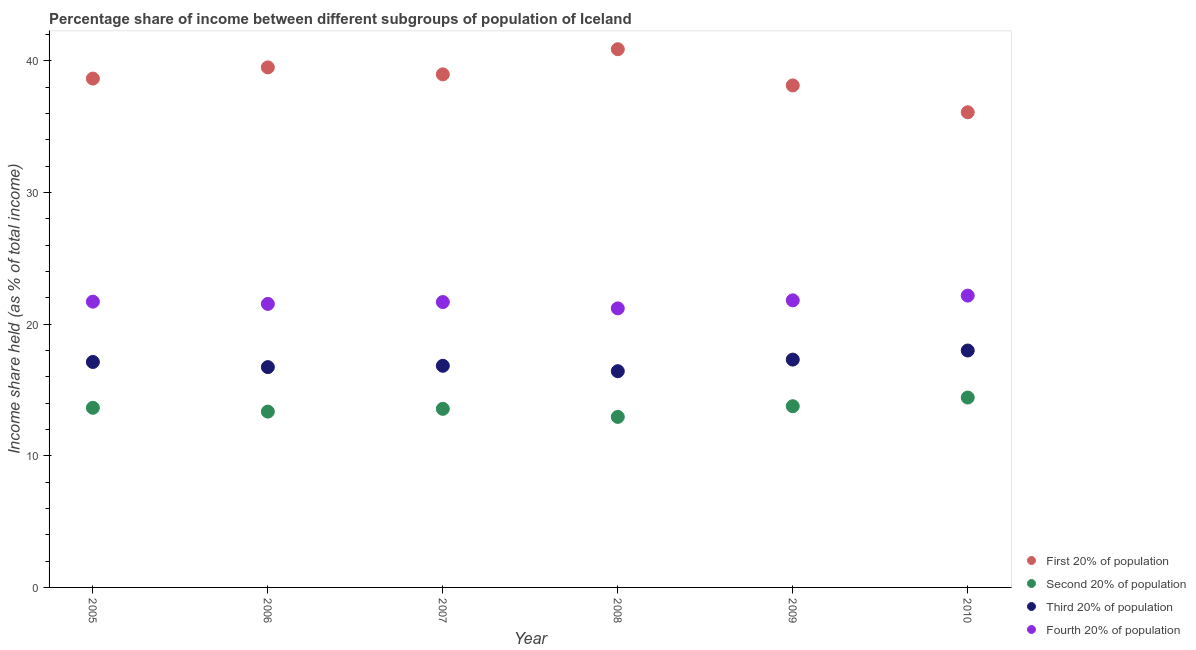How many different coloured dotlines are there?
Your response must be concise. 4. Is the number of dotlines equal to the number of legend labels?
Your answer should be very brief. Yes. What is the share of the income held by fourth 20% of the population in 2008?
Offer a terse response. 21.19. Across all years, what is the maximum share of the income held by fourth 20% of the population?
Offer a very short reply. 22.16. Across all years, what is the minimum share of the income held by first 20% of the population?
Ensure brevity in your answer.  36.08. What is the total share of the income held by fourth 20% of the population in the graph?
Your answer should be very brief. 130.05. What is the difference between the share of the income held by fourth 20% of the population in 2006 and that in 2008?
Your answer should be very brief. 0.34. What is the difference between the share of the income held by second 20% of the population in 2007 and the share of the income held by third 20% of the population in 2009?
Ensure brevity in your answer.  -3.74. What is the average share of the income held by second 20% of the population per year?
Ensure brevity in your answer.  13.61. In the year 2009, what is the difference between the share of the income held by second 20% of the population and share of the income held by third 20% of the population?
Your answer should be very brief. -3.54. What is the ratio of the share of the income held by fourth 20% of the population in 2005 to that in 2009?
Provide a short and direct response. 1. Is the share of the income held by second 20% of the population in 2005 less than that in 2006?
Your answer should be compact. No. What is the difference between the highest and the second highest share of the income held by fourth 20% of the population?
Your answer should be compact. 0.36. What is the difference between the highest and the lowest share of the income held by second 20% of the population?
Keep it short and to the point. 1.47. In how many years, is the share of the income held by second 20% of the population greater than the average share of the income held by second 20% of the population taken over all years?
Provide a succinct answer. 3. Is the sum of the share of the income held by third 20% of the population in 2007 and 2009 greater than the maximum share of the income held by second 20% of the population across all years?
Offer a very short reply. Yes. Is it the case that in every year, the sum of the share of the income held by first 20% of the population and share of the income held by fourth 20% of the population is greater than the sum of share of the income held by third 20% of the population and share of the income held by second 20% of the population?
Your answer should be compact. Yes. How many dotlines are there?
Provide a succinct answer. 4. What is the difference between two consecutive major ticks on the Y-axis?
Offer a terse response. 10. Does the graph contain grids?
Provide a succinct answer. No. How many legend labels are there?
Make the answer very short. 4. How are the legend labels stacked?
Make the answer very short. Vertical. What is the title of the graph?
Your answer should be compact. Percentage share of income between different subgroups of population of Iceland. What is the label or title of the X-axis?
Your response must be concise. Year. What is the label or title of the Y-axis?
Your answer should be compact. Income share held (as % of total income). What is the Income share held (as % of total income) of First 20% of population in 2005?
Give a very brief answer. 38.64. What is the Income share held (as % of total income) in Second 20% of population in 2005?
Make the answer very short. 13.64. What is the Income share held (as % of total income) in Third 20% of population in 2005?
Provide a succinct answer. 17.12. What is the Income share held (as % of total income) of Fourth 20% of population in 2005?
Give a very brief answer. 21.7. What is the Income share held (as % of total income) in First 20% of population in 2006?
Make the answer very short. 39.49. What is the Income share held (as % of total income) of Second 20% of population in 2006?
Ensure brevity in your answer.  13.35. What is the Income share held (as % of total income) in Third 20% of population in 2006?
Make the answer very short. 16.73. What is the Income share held (as % of total income) of Fourth 20% of population in 2006?
Make the answer very short. 21.53. What is the Income share held (as % of total income) in First 20% of population in 2007?
Make the answer very short. 38.96. What is the Income share held (as % of total income) of Second 20% of population in 2007?
Ensure brevity in your answer.  13.56. What is the Income share held (as % of total income) of Third 20% of population in 2007?
Keep it short and to the point. 16.83. What is the Income share held (as % of total income) in Fourth 20% of population in 2007?
Keep it short and to the point. 21.67. What is the Income share held (as % of total income) in First 20% of population in 2008?
Offer a very short reply. 40.87. What is the Income share held (as % of total income) in Second 20% of population in 2008?
Provide a succinct answer. 12.95. What is the Income share held (as % of total income) of Third 20% of population in 2008?
Offer a very short reply. 16.42. What is the Income share held (as % of total income) in Fourth 20% of population in 2008?
Make the answer very short. 21.19. What is the Income share held (as % of total income) of First 20% of population in 2009?
Make the answer very short. 38.12. What is the Income share held (as % of total income) of Second 20% of population in 2009?
Your answer should be compact. 13.76. What is the Income share held (as % of total income) of Third 20% of population in 2009?
Your answer should be very brief. 17.3. What is the Income share held (as % of total income) of Fourth 20% of population in 2009?
Provide a succinct answer. 21.8. What is the Income share held (as % of total income) in First 20% of population in 2010?
Provide a short and direct response. 36.08. What is the Income share held (as % of total income) of Second 20% of population in 2010?
Give a very brief answer. 14.42. What is the Income share held (as % of total income) in Third 20% of population in 2010?
Ensure brevity in your answer.  17.99. What is the Income share held (as % of total income) in Fourth 20% of population in 2010?
Give a very brief answer. 22.16. Across all years, what is the maximum Income share held (as % of total income) in First 20% of population?
Your answer should be very brief. 40.87. Across all years, what is the maximum Income share held (as % of total income) in Second 20% of population?
Your answer should be compact. 14.42. Across all years, what is the maximum Income share held (as % of total income) in Third 20% of population?
Ensure brevity in your answer.  17.99. Across all years, what is the maximum Income share held (as % of total income) in Fourth 20% of population?
Keep it short and to the point. 22.16. Across all years, what is the minimum Income share held (as % of total income) in First 20% of population?
Your answer should be compact. 36.08. Across all years, what is the minimum Income share held (as % of total income) in Second 20% of population?
Ensure brevity in your answer.  12.95. Across all years, what is the minimum Income share held (as % of total income) in Third 20% of population?
Make the answer very short. 16.42. Across all years, what is the minimum Income share held (as % of total income) in Fourth 20% of population?
Your answer should be very brief. 21.19. What is the total Income share held (as % of total income) in First 20% of population in the graph?
Provide a succinct answer. 232.16. What is the total Income share held (as % of total income) of Second 20% of population in the graph?
Keep it short and to the point. 81.68. What is the total Income share held (as % of total income) in Third 20% of population in the graph?
Offer a terse response. 102.39. What is the total Income share held (as % of total income) of Fourth 20% of population in the graph?
Offer a terse response. 130.05. What is the difference between the Income share held (as % of total income) in First 20% of population in 2005 and that in 2006?
Make the answer very short. -0.85. What is the difference between the Income share held (as % of total income) of Second 20% of population in 2005 and that in 2006?
Give a very brief answer. 0.29. What is the difference between the Income share held (as % of total income) in Third 20% of population in 2005 and that in 2006?
Keep it short and to the point. 0.39. What is the difference between the Income share held (as % of total income) of Fourth 20% of population in 2005 and that in 2006?
Provide a short and direct response. 0.17. What is the difference between the Income share held (as % of total income) of First 20% of population in 2005 and that in 2007?
Provide a short and direct response. -0.32. What is the difference between the Income share held (as % of total income) in Third 20% of population in 2005 and that in 2007?
Offer a terse response. 0.29. What is the difference between the Income share held (as % of total income) of Fourth 20% of population in 2005 and that in 2007?
Keep it short and to the point. 0.03. What is the difference between the Income share held (as % of total income) of First 20% of population in 2005 and that in 2008?
Make the answer very short. -2.23. What is the difference between the Income share held (as % of total income) in Second 20% of population in 2005 and that in 2008?
Keep it short and to the point. 0.69. What is the difference between the Income share held (as % of total income) of Fourth 20% of population in 2005 and that in 2008?
Offer a terse response. 0.51. What is the difference between the Income share held (as % of total income) of First 20% of population in 2005 and that in 2009?
Offer a very short reply. 0.52. What is the difference between the Income share held (as % of total income) in Second 20% of population in 2005 and that in 2009?
Your answer should be very brief. -0.12. What is the difference between the Income share held (as % of total income) in Third 20% of population in 2005 and that in 2009?
Ensure brevity in your answer.  -0.18. What is the difference between the Income share held (as % of total income) of Fourth 20% of population in 2005 and that in 2009?
Make the answer very short. -0.1. What is the difference between the Income share held (as % of total income) of First 20% of population in 2005 and that in 2010?
Provide a short and direct response. 2.56. What is the difference between the Income share held (as % of total income) of Second 20% of population in 2005 and that in 2010?
Offer a very short reply. -0.78. What is the difference between the Income share held (as % of total income) of Third 20% of population in 2005 and that in 2010?
Offer a very short reply. -0.87. What is the difference between the Income share held (as % of total income) in Fourth 20% of population in 2005 and that in 2010?
Provide a succinct answer. -0.46. What is the difference between the Income share held (as % of total income) in First 20% of population in 2006 and that in 2007?
Offer a very short reply. 0.53. What is the difference between the Income share held (as % of total income) of Second 20% of population in 2006 and that in 2007?
Offer a very short reply. -0.21. What is the difference between the Income share held (as % of total income) in Fourth 20% of population in 2006 and that in 2007?
Offer a very short reply. -0.14. What is the difference between the Income share held (as % of total income) of First 20% of population in 2006 and that in 2008?
Offer a terse response. -1.38. What is the difference between the Income share held (as % of total income) of Third 20% of population in 2006 and that in 2008?
Your response must be concise. 0.31. What is the difference between the Income share held (as % of total income) in Fourth 20% of population in 2006 and that in 2008?
Your response must be concise. 0.34. What is the difference between the Income share held (as % of total income) of First 20% of population in 2006 and that in 2009?
Your answer should be very brief. 1.37. What is the difference between the Income share held (as % of total income) of Second 20% of population in 2006 and that in 2009?
Your answer should be compact. -0.41. What is the difference between the Income share held (as % of total income) in Third 20% of population in 2006 and that in 2009?
Offer a very short reply. -0.57. What is the difference between the Income share held (as % of total income) of Fourth 20% of population in 2006 and that in 2009?
Your response must be concise. -0.27. What is the difference between the Income share held (as % of total income) of First 20% of population in 2006 and that in 2010?
Provide a succinct answer. 3.41. What is the difference between the Income share held (as % of total income) of Second 20% of population in 2006 and that in 2010?
Offer a very short reply. -1.07. What is the difference between the Income share held (as % of total income) of Third 20% of population in 2006 and that in 2010?
Ensure brevity in your answer.  -1.26. What is the difference between the Income share held (as % of total income) of Fourth 20% of population in 2006 and that in 2010?
Ensure brevity in your answer.  -0.63. What is the difference between the Income share held (as % of total income) of First 20% of population in 2007 and that in 2008?
Your answer should be very brief. -1.91. What is the difference between the Income share held (as % of total income) in Second 20% of population in 2007 and that in 2008?
Your response must be concise. 0.61. What is the difference between the Income share held (as % of total income) in Third 20% of population in 2007 and that in 2008?
Offer a terse response. 0.41. What is the difference between the Income share held (as % of total income) of Fourth 20% of population in 2007 and that in 2008?
Offer a terse response. 0.48. What is the difference between the Income share held (as % of total income) in First 20% of population in 2007 and that in 2009?
Your answer should be compact. 0.84. What is the difference between the Income share held (as % of total income) of Second 20% of population in 2007 and that in 2009?
Your response must be concise. -0.2. What is the difference between the Income share held (as % of total income) in Third 20% of population in 2007 and that in 2009?
Your answer should be very brief. -0.47. What is the difference between the Income share held (as % of total income) of Fourth 20% of population in 2007 and that in 2009?
Offer a terse response. -0.13. What is the difference between the Income share held (as % of total income) of First 20% of population in 2007 and that in 2010?
Provide a succinct answer. 2.88. What is the difference between the Income share held (as % of total income) in Second 20% of population in 2007 and that in 2010?
Offer a very short reply. -0.86. What is the difference between the Income share held (as % of total income) in Third 20% of population in 2007 and that in 2010?
Your response must be concise. -1.16. What is the difference between the Income share held (as % of total income) in Fourth 20% of population in 2007 and that in 2010?
Your response must be concise. -0.49. What is the difference between the Income share held (as % of total income) in First 20% of population in 2008 and that in 2009?
Your answer should be compact. 2.75. What is the difference between the Income share held (as % of total income) of Second 20% of population in 2008 and that in 2009?
Keep it short and to the point. -0.81. What is the difference between the Income share held (as % of total income) of Third 20% of population in 2008 and that in 2009?
Ensure brevity in your answer.  -0.88. What is the difference between the Income share held (as % of total income) of Fourth 20% of population in 2008 and that in 2009?
Give a very brief answer. -0.61. What is the difference between the Income share held (as % of total income) in First 20% of population in 2008 and that in 2010?
Your answer should be very brief. 4.79. What is the difference between the Income share held (as % of total income) of Second 20% of population in 2008 and that in 2010?
Your answer should be very brief. -1.47. What is the difference between the Income share held (as % of total income) of Third 20% of population in 2008 and that in 2010?
Ensure brevity in your answer.  -1.57. What is the difference between the Income share held (as % of total income) of Fourth 20% of population in 2008 and that in 2010?
Make the answer very short. -0.97. What is the difference between the Income share held (as % of total income) of First 20% of population in 2009 and that in 2010?
Give a very brief answer. 2.04. What is the difference between the Income share held (as % of total income) in Second 20% of population in 2009 and that in 2010?
Offer a very short reply. -0.66. What is the difference between the Income share held (as % of total income) of Third 20% of population in 2009 and that in 2010?
Give a very brief answer. -0.69. What is the difference between the Income share held (as % of total income) in Fourth 20% of population in 2009 and that in 2010?
Offer a terse response. -0.36. What is the difference between the Income share held (as % of total income) in First 20% of population in 2005 and the Income share held (as % of total income) in Second 20% of population in 2006?
Provide a short and direct response. 25.29. What is the difference between the Income share held (as % of total income) in First 20% of population in 2005 and the Income share held (as % of total income) in Third 20% of population in 2006?
Offer a very short reply. 21.91. What is the difference between the Income share held (as % of total income) in First 20% of population in 2005 and the Income share held (as % of total income) in Fourth 20% of population in 2006?
Your response must be concise. 17.11. What is the difference between the Income share held (as % of total income) of Second 20% of population in 2005 and the Income share held (as % of total income) of Third 20% of population in 2006?
Your response must be concise. -3.09. What is the difference between the Income share held (as % of total income) of Second 20% of population in 2005 and the Income share held (as % of total income) of Fourth 20% of population in 2006?
Offer a very short reply. -7.89. What is the difference between the Income share held (as % of total income) in Third 20% of population in 2005 and the Income share held (as % of total income) in Fourth 20% of population in 2006?
Your answer should be very brief. -4.41. What is the difference between the Income share held (as % of total income) in First 20% of population in 2005 and the Income share held (as % of total income) in Second 20% of population in 2007?
Give a very brief answer. 25.08. What is the difference between the Income share held (as % of total income) in First 20% of population in 2005 and the Income share held (as % of total income) in Third 20% of population in 2007?
Your response must be concise. 21.81. What is the difference between the Income share held (as % of total income) in First 20% of population in 2005 and the Income share held (as % of total income) in Fourth 20% of population in 2007?
Ensure brevity in your answer.  16.97. What is the difference between the Income share held (as % of total income) in Second 20% of population in 2005 and the Income share held (as % of total income) in Third 20% of population in 2007?
Provide a short and direct response. -3.19. What is the difference between the Income share held (as % of total income) of Second 20% of population in 2005 and the Income share held (as % of total income) of Fourth 20% of population in 2007?
Your answer should be very brief. -8.03. What is the difference between the Income share held (as % of total income) in Third 20% of population in 2005 and the Income share held (as % of total income) in Fourth 20% of population in 2007?
Give a very brief answer. -4.55. What is the difference between the Income share held (as % of total income) of First 20% of population in 2005 and the Income share held (as % of total income) of Second 20% of population in 2008?
Your answer should be compact. 25.69. What is the difference between the Income share held (as % of total income) in First 20% of population in 2005 and the Income share held (as % of total income) in Third 20% of population in 2008?
Make the answer very short. 22.22. What is the difference between the Income share held (as % of total income) of First 20% of population in 2005 and the Income share held (as % of total income) of Fourth 20% of population in 2008?
Keep it short and to the point. 17.45. What is the difference between the Income share held (as % of total income) of Second 20% of population in 2005 and the Income share held (as % of total income) of Third 20% of population in 2008?
Offer a very short reply. -2.78. What is the difference between the Income share held (as % of total income) in Second 20% of population in 2005 and the Income share held (as % of total income) in Fourth 20% of population in 2008?
Your response must be concise. -7.55. What is the difference between the Income share held (as % of total income) in Third 20% of population in 2005 and the Income share held (as % of total income) in Fourth 20% of population in 2008?
Give a very brief answer. -4.07. What is the difference between the Income share held (as % of total income) in First 20% of population in 2005 and the Income share held (as % of total income) in Second 20% of population in 2009?
Your answer should be very brief. 24.88. What is the difference between the Income share held (as % of total income) in First 20% of population in 2005 and the Income share held (as % of total income) in Third 20% of population in 2009?
Offer a terse response. 21.34. What is the difference between the Income share held (as % of total income) of First 20% of population in 2005 and the Income share held (as % of total income) of Fourth 20% of population in 2009?
Provide a succinct answer. 16.84. What is the difference between the Income share held (as % of total income) in Second 20% of population in 2005 and the Income share held (as % of total income) in Third 20% of population in 2009?
Provide a short and direct response. -3.66. What is the difference between the Income share held (as % of total income) in Second 20% of population in 2005 and the Income share held (as % of total income) in Fourth 20% of population in 2009?
Give a very brief answer. -8.16. What is the difference between the Income share held (as % of total income) in Third 20% of population in 2005 and the Income share held (as % of total income) in Fourth 20% of population in 2009?
Ensure brevity in your answer.  -4.68. What is the difference between the Income share held (as % of total income) in First 20% of population in 2005 and the Income share held (as % of total income) in Second 20% of population in 2010?
Your answer should be very brief. 24.22. What is the difference between the Income share held (as % of total income) of First 20% of population in 2005 and the Income share held (as % of total income) of Third 20% of population in 2010?
Give a very brief answer. 20.65. What is the difference between the Income share held (as % of total income) in First 20% of population in 2005 and the Income share held (as % of total income) in Fourth 20% of population in 2010?
Keep it short and to the point. 16.48. What is the difference between the Income share held (as % of total income) in Second 20% of population in 2005 and the Income share held (as % of total income) in Third 20% of population in 2010?
Provide a short and direct response. -4.35. What is the difference between the Income share held (as % of total income) in Second 20% of population in 2005 and the Income share held (as % of total income) in Fourth 20% of population in 2010?
Your response must be concise. -8.52. What is the difference between the Income share held (as % of total income) in Third 20% of population in 2005 and the Income share held (as % of total income) in Fourth 20% of population in 2010?
Your answer should be compact. -5.04. What is the difference between the Income share held (as % of total income) in First 20% of population in 2006 and the Income share held (as % of total income) in Second 20% of population in 2007?
Provide a succinct answer. 25.93. What is the difference between the Income share held (as % of total income) of First 20% of population in 2006 and the Income share held (as % of total income) of Third 20% of population in 2007?
Keep it short and to the point. 22.66. What is the difference between the Income share held (as % of total income) in First 20% of population in 2006 and the Income share held (as % of total income) in Fourth 20% of population in 2007?
Make the answer very short. 17.82. What is the difference between the Income share held (as % of total income) in Second 20% of population in 2006 and the Income share held (as % of total income) in Third 20% of population in 2007?
Your answer should be compact. -3.48. What is the difference between the Income share held (as % of total income) in Second 20% of population in 2006 and the Income share held (as % of total income) in Fourth 20% of population in 2007?
Offer a terse response. -8.32. What is the difference between the Income share held (as % of total income) of Third 20% of population in 2006 and the Income share held (as % of total income) of Fourth 20% of population in 2007?
Offer a very short reply. -4.94. What is the difference between the Income share held (as % of total income) of First 20% of population in 2006 and the Income share held (as % of total income) of Second 20% of population in 2008?
Ensure brevity in your answer.  26.54. What is the difference between the Income share held (as % of total income) in First 20% of population in 2006 and the Income share held (as % of total income) in Third 20% of population in 2008?
Your answer should be compact. 23.07. What is the difference between the Income share held (as % of total income) in Second 20% of population in 2006 and the Income share held (as % of total income) in Third 20% of population in 2008?
Ensure brevity in your answer.  -3.07. What is the difference between the Income share held (as % of total income) in Second 20% of population in 2006 and the Income share held (as % of total income) in Fourth 20% of population in 2008?
Give a very brief answer. -7.84. What is the difference between the Income share held (as % of total income) of Third 20% of population in 2006 and the Income share held (as % of total income) of Fourth 20% of population in 2008?
Ensure brevity in your answer.  -4.46. What is the difference between the Income share held (as % of total income) in First 20% of population in 2006 and the Income share held (as % of total income) in Second 20% of population in 2009?
Offer a terse response. 25.73. What is the difference between the Income share held (as % of total income) of First 20% of population in 2006 and the Income share held (as % of total income) of Third 20% of population in 2009?
Provide a short and direct response. 22.19. What is the difference between the Income share held (as % of total income) in First 20% of population in 2006 and the Income share held (as % of total income) in Fourth 20% of population in 2009?
Your response must be concise. 17.69. What is the difference between the Income share held (as % of total income) of Second 20% of population in 2006 and the Income share held (as % of total income) of Third 20% of population in 2009?
Keep it short and to the point. -3.95. What is the difference between the Income share held (as % of total income) of Second 20% of population in 2006 and the Income share held (as % of total income) of Fourth 20% of population in 2009?
Keep it short and to the point. -8.45. What is the difference between the Income share held (as % of total income) in Third 20% of population in 2006 and the Income share held (as % of total income) in Fourth 20% of population in 2009?
Provide a short and direct response. -5.07. What is the difference between the Income share held (as % of total income) of First 20% of population in 2006 and the Income share held (as % of total income) of Second 20% of population in 2010?
Your answer should be compact. 25.07. What is the difference between the Income share held (as % of total income) in First 20% of population in 2006 and the Income share held (as % of total income) in Fourth 20% of population in 2010?
Give a very brief answer. 17.33. What is the difference between the Income share held (as % of total income) in Second 20% of population in 2006 and the Income share held (as % of total income) in Third 20% of population in 2010?
Your response must be concise. -4.64. What is the difference between the Income share held (as % of total income) of Second 20% of population in 2006 and the Income share held (as % of total income) of Fourth 20% of population in 2010?
Your response must be concise. -8.81. What is the difference between the Income share held (as % of total income) in Third 20% of population in 2006 and the Income share held (as % of total income) in Fourth 20% of population in 2010?
Make the answer very short. -5.43. What is the difference between the Income share held (as % of total income) in First 20% of population in 2007 and the Income share held (as % of total income) in Second 20% of population in 2008?
Offer a very short reply. 26.01. What is the difference between the Income share held (as % of total income) in First 20% of population in 2007 and the Income share held (as % of total income) in Third 20% of population in 2008?
Ensure brevity in your answer.  22.54. What is the difference between the Income share held (as % of total income) of First 20% of population in 2007 and the Income share held (as % of total income) of Fourth 20% of population in 2008?
Provide a short and direct response. 17.77. What is the difference between the Income share held (as % of total income) in Second 20% of population in 2007 and the Income share held (as % of total income) in Third 20% of population in 2008?
Your answer should be compact. -2.86. What is the difference between the Income share held (as % of total income) of Second 20% of population in 2007 and the Income share held (as % of total income) of Fourth 20% of population in 2008?
Offer a terse response. -7.63. What is the difference between the Income share held (as % of total income) in Third 20% of population in 2007 and the Income share held (as % of total income) in Fourth 20% of population in 2008?
Your answer should be very brief. -4.36. What is the difference between the Income share held (as % of total income) of First 20% of population in 2007 and the Income share held (as % of total income) of Second 20% of population in 2009?
Your answer should be compact. 25.2. What is the difference between the Income share held (as % of total income) of First 20% of population in 2007 and the Income share held (as % of total income) of Third 20% of population in 2009?
Provide a succinct answer. 21.66. What is the difference between the Income share held (as % of total income) in First 20% of population in 2007 and the Income share held (as % of total income) in Fourth 20% of population in 2009?
Your response must be concise. 17.16. What is the difference between the Income share held (as % of total income) of Second 20% of population in 2007 and the Income share held (as % of total income) of Third 20% of population in 2009?
Ensure brevity in your answer.  -3.74. What is the difference between the Income share held (as % of total income) of Second 20% of population in 2007 and the Income share held (as % of total income) of Fourth 20% of population in 2009?
Offer a very short reply. -8.24. What is the difference between the Income share held (as % of total income) of Third 20% of population in 2007 and the Income share held (as % of total income) of Fourth 20% of population in 2009?
Offer a very short reply. -4.97. What is the difference between the Income share held (as % of total income) of First 20% of population in 2007 and the Income share held (as % of total income) of Second 20% of population in 2010?
Make the answer very short. 24.54. What is the difference between the Income share held (as % of total income) of First 20% of population in 2007 and the Income share held (as % of total income) of Third 20% of population in 2010?
Provide a succinct answer. 20.97. What is the difference between the Income share held (as % of total income) in Second 20% of population in 2007 and the Income share held (as % of total income) in Third 20% of population in 2010?
Provide a succinct answer. -4.43. What is the difference between the Income share held (as % of total income) of Second 20% of population in 2007 and the Income share held (as % of total income) of Fourth 20% of population in 2010?
Keep it short and to the point. -8.6. What is the difference between the Income share held (as % of total income) of Third 20% of population in 2007 and the Income share held (as % of total income) of Fourth 20% of population in 2010?
Your response must be concise. -5.33. What is the difference between the Income share held (as % of total income) in First 20% of population in 2008 and the Income share held (as % of total income) in Second 20% of population in 2009?
Your answer should be very brief. 27.11. What is the difference between the Income share held (as % of total income) of First 20% of population in 2008 and the Income share held (as % of total income) of Third 20% of population in 2009?
Keep it short and to the point. 23.57. What is the difference between the Income share held (as % of total income) in First 20% of population in 2008 and the Income share held (as % of total income) in Fourth 20% of population in 2009?
Ensure brevity in your answer.  19.07. What is the difference between the Income share held (as % of total income) in Second 20% of population in 2008 and the Income share held (as % of total income) in Third 20% of population in 2009?
Provide a succinct answer. -4.35. What is the difference between the Income share held (as % of total income) in Second 20% of population in 2008 and the Income share held (as % of total income) in Fourth 20% of population in 2009?
Your answer should be compact. -8.85. What is the difference between the Income share held (as % of total income) in Third 20% of population in 2008 and the Income share held (as % of total income) in Fourth 20% of population in 2009?
Offer a very short reply. -5.38. What is the difference between the Income share held (as % of total income) in First 20% of population in 2008 and the Income share held (as % of total income) in Second 20% of population in 2010?
Your response must be concise. 26.45. What is the difference between the Income share held (as % of total income) of First 20% of population in 2008 and the Income share held (as % of total income) of Third 20% of population in 2010?
Your response must be concise. 22.88. What is the difference between the Income share held (as % of total income) of First 20% of population in 2008 and the Income share held (as % of total income) of Fourth 20% of population in 2010?
Your response must be concise. 18.71. What is the difference between the Income share held (as % of total income) in Second 20% of population in 2008 and the Income share held (as % of total income) in Third 20% of population in 2010?
Offer a very short reply. -5.04. What is the difference between the Income share held (as % of total income) in Second 20% of population in 2008 and the Income share held (as % of total income) in Fourth 20% of population in 2010?
Ensure brevity in your answer.  -9.21. What is the difference between the Income share held (as % of total income) of Third 20% of population in 2008 and the Income share held (as % of total income) of Fourth 20% of population in 2010?
Your answer should be compact. -5.74. What is the difference between the Income share held (as % of total income) in First 20% of population in 2009 and the Income share held (as % of total income) in Second 20% of population in 2010?
Offer a very short reply. 23.7. What is the difference between the Income share held (as % of total income) of First 20% of population in 2009 and the Income share held (as % of total income) of Third 20% of population in 2010?
Provide a short and direct response. 20.13. What is the difference between the Income share held (as % of total income) of First 20% of population in 2009 and the Income share held (as % of total income) of Fourth 20% of population in 2010?
Your answer should be very brief. 15.96. What is the difference between the Income share held (as % of total income) in Second 20% of population in 2009 and the Income share held (as % of total income) in Third 20% of population in 2010?
Offer a terse response. -4.23. What is the difference between the Income share held (as % of total income) of Second 20% of population in 2009 and the Income share held (as % of total income) of Fourth 20% of population in 2010?
Give a very brief answer. -8.4. What is the difference between the Income share held (as % of total income) of Third 20% of population in 2009 and the Income share held (as % of total income) of Fourth 20% of population in 2010?
Your answer should be very brief. -4.86. What is the average Income share held (as % of total income) in First 20% of population per year?
Ensure brevity in your answer.  38.69. What is the average Income share held (as % of total income) in Second 20% of population per year?
Ensure brevity in your answer.  13.61. What is the average Income share held (as % of total income) in Third 20% of population per year?
Make the answer very short. 17.07. What is the average Income share held (as % of total income) of Fourth 20% of population per year?
Make the answer very short. 21.68. In the year 2005, what is the difference between the Income share held (as % of total income) in First 20% of population and Income share held (as % of total income) in Second 20% of population?
Ensure brevity in your answer.  25. In the year 2005, what is the difference between the Income share held (as % of total income) of First 20% of population and Income share held (as % of total income) of Third 20% of population?
Your response must be concise. 21.52. In the year 2005, what is the difference between the Income share held (as % of total income) in First 20% of population and Income share held (as % of total income) in Fourth 20% of population?
Offer a terse response. 16.94. In the year 2005, what is the difference between the Income share held (as % of total income) of Second 20% of population and Income share held (as % of total income) of Third 20% of population?
Your response must be concise. -3.48. In the year 2005, what is the difference between the Income share held (as % of total income) of Second 20% of population and Income share held (as % of total income) of Fourth 20% of population?
Provide a succinct answer. -8.06. In the year 2005, what is the difference between the Income share held (as % of total income) of Third 20% of population and Income share held (as % of total income) of Fourth 20% of population?
Keep it short and to the point. -4.58. In the year 2006, what is the difference between the Income share held (as % of total income) in First 20% of population and Income share held (as % of total income) in Second 20% of population?
Your answer should be compact. 26.14. In the year 2006, what is the difference between the Income share held (as % of total income) in First 20% of population and Income share held (as % of total income) in Third 20% of population?
Ensure brevity in your answer.  22.76. In the year 2006, what is the difference between the Income share held (as % of total income) of First 20% of population and Income share held (as % of total income) of Fourth 20% of population?
Your answer should be compact. 17.96. In the year 2006, what is the difference between the Income share held (as % of total income) in Second 20% of population and Income share held (as % of total income) in Third 20% of population?
Offer a terse response. -3.38. In the year 2006, what is the difference between the Income share held (as % of total income) in Second 20% of population and Income share held (as % of total income) in Fourth 20% of population?
Give a very brief answer. -8.18. In the year 2007, what is the difference between the Income share held (as % of total income) in First 20% of population and Income share held (as % of total income) in Second 20% of population?
Provide a short and direct response. 25.4. In the year 2007, what is the difference between the Income share held (as % of total income) of First 20% of population and Income share held (as % of total income) of Third 20% of population?
Make the answer very short. 22.13. In the year 2007, what is the difference between the Income share held (as % of total income) of First 20% of population and Income share held (as % of total income) of Fourth 20% of population?
Keep it short and to the point. 17.29. In the year 2007, what is the difference between the Income share held (as % of total income) of Second 20% of population and Income share held (as % of total income) of Third 20% of population?
Provide a short and direct response. -3.27. In the year 2007, what is the difference between the Income share held (as % of total income) in Second 20% of population and Income share held (as % of total income) in Fourth 20% of population?
Provide a short and direct response. -8.11. In the year 2007, what is the difference between the Income share held (as % of total income) of Third 20% of population and Income share held (as % of total income) of Fourth 20% of population?
Make the answer very short. -4.84. In the year 2008, what is the difference between the Income share held (as % of total income) in First 20% of population and Income share held (as % of total income) in Second 20% of population?
Ensure brevity in your answer.  27.92. In the year 2008, what is the difference between the Income share held (as % of total income) of First 20% of population and Income share held (as % of total income) of Third 20% of population?
Provide a succinct answer. 24.45. In the year 2008, what is the difference between the Income share held (as % of total income) in First 20% of population and Income share held (as % of total income) in Fourth 20% of population?
Give a very brief answer. 19.68. In the year 2008, what is the difference between the Income share held (as % of total income) of Second 20% of population and Income share held (as % of total income) of Third 20% of population?
Keep it short and to the point. -3.47. In the year 2008, what is the difference between the Income share held (as % of total income) in Second 20% of population and Income share held (as % of total income) in Fourth 20% of population?
Offer a very short reply. -8.24. In the year 2008, what is the difference between the Income share held (as % of total income) in Third 20% of population and Income share held (as % of total income) in Fourth 20% of population?
Give a very brief answer. -4.77. In the year 2009, what is the difference between the Income share held (as % of total income) in First 20% of population and Income share held (as % of total income) in Second 20% of population?
Offer a terse response. 24.36. In the year 2009, what is the difference between the Income share held (as % of total income) in First 20% of population and Income share held (as % of total income) in Third 20% of population?
Your answer should be compact. 20.82. In the year 2009, what is the difference between the Income share held (as % of total income) of First 20% of population and Income share held (as % of total income) of Fourth 20% of population?
Your answer should be compact. 16.32. In the year 2009, what is the difference between the Income share held (as % of total income) of Second 20% of population and Income share held (as % of total income) of Third 20% of population?
Your answer should be compact. -3.54. In the year 2009, what is the difference between the Income share held (as % of total income) of Second 20% of population and Income share held (as % of total income) of Fourth 20% of population?
Offer a very short reply. -8.04. In the year 2009, what is the difference between the Income share held (as % of total income) of Third 20% of population and Income share held (as % of total income) of Fourth 20% of population?
Your answer should be compact. -4.5. In the year 2010, what is the difference between the Income share held (as % of total income) in First 20% of population and Income share held (as % of total income) in Second 20% of population?
Provide a succinct answer. 21.66. In the year 2010, what is the difference between the Income share held (as % of total income) in First 20% of population and Income share held (as % of total income) in Third 20% of population?
Provide a succinct answer. 18.09. In the year 2010, what is the difference between the Income share held (as % of total income) of First 20% of population and Income share held (as % of total income) of Fourth 20% of population?
Ensure brevity in your answer.  13.92. In the year 2010, what is the difference between the Income share held (as % of total income) of Second 20% of population and Income share held (as % of total income) of Third 20% of population?
Your answer should be very brief. -3.57. In the year 2010, what is the difference between the Income share held (as % of total income) in Second 20% of population and Income share held (as % of total income) in Fourth 20% of population?
Ensure brevity in your answer.  -7.74. In the year 2010, what is the difference between the Income share held (as % of total income) of Third 20% of population and Income share held (as % of total income) of Fourth 20% of population?
Give a very brief answer. -4.17. What is the ratio of the Income share held (as % of total income) of First 20% of population in 2005 to that in 2006?
Your answer should be very brief. 0.98. What is the ratio of the Income share held (as % of total income) in Second 20% of population in 2005 to that in 2006?
Your answer should be compact. 1.02. What is the ratio of the Income share held (as % of total income) in Third 20% of population in 2005 to that in 2006?
Offer a terse response. 1.02. What is the ratio of the Income share held (as % of total income) of Fourth 20% of population in 2005 to that in 2006?
Give a very brief answer. 1.01. What is the ratio of the Income share held (as % of total income) of Second 20% of population in 2005 to that in 2007?
Your answer should be compact. 1.01. What is the ratio of the Income share held (as % of total income) in Third 20% of population in 2005 to that in 2007?
Offer a very short reply. 1.02. What is the ratio of the Income share held (as % of total income) in First 20% of population in 2005 to that in 2008?
Give a very brief answer. 0.95. What is the ratio of the Income share held (as % of total income) of Second 20% of population in 2005 to that in 2008?
Provide a succinct answer. 1.05. What is the ratio of the Income share held (as % of total income) of Third 20% of population in 2005 to that in 2008?
Keep it short and to the point. 1.04. What is the ratio of the Income share held (as % of total income) of Fourth 20% of population in 2005 to that in 2008?
Provide a succinct answer. 1.02. What is the ratio of the Income share held (as % of total income) in First 20% of population in 2005 to that in 2009?
Provide a short and direct response. 1.01. What is the ratio of the Income share held (as % of total income) in First 20% of population in 2005 to that in 2010?
Provide a short and direct response. 1.07. What is the ratio of the Income share held (as % of total income) in Second 20% of population in 2005 to that in 2010?
Offer a very short reply. 0.95. What is the ratio of the Income share held (as % of total income) of Third 20% of population in 2005 to that in 2010?
Offer a very short reply. 0.95. What is the ratio of the Income share held (as % of total income) in Fourth 20% of population in 2005 to that in 2010?
Your response must be concise. 0.98. What is the ratio of the Income share held (as % of total income) in First 20% of population in 2006 to that in 2007?
Keep it short and to the point. 1.01. What is the ratio of the Income share held (as % of total income) in Second 20% of population in 2006 to that in 2007?
Your response must be concise. 0.98. What is the ratio of the Income share held (as % of total income) of First 20% of population in 2006 to that in 2008?
Ensure brevity in your answer.  0.97. What is the ratio of the Income share held (as % of total income) of Second 20% of population in 2006 to that in 2008?
Ensure brevity in your answer.  1.03. What is the ratio of the Income share held (as % of total income) of Third 20% of population in 2006 to that in 2008?
Offer a terse response. 1.02. What is the ratio of the Income share held (as % of total income) of First 20% of population in 2006 to that in 2009?
Make the answer very short. 1.04. What is the ratio of the Income share held (as % of total income) of Second 20% of population in 2006 to that in 2009?
Ensure brevity in your answer.  0.97. What is the ratio of the Income share held (as % of total income) of Third 20% of population in 2006 to that in 2009?
Your answer should be compact. 0.97. What is the ratio of the Income share held (as % of total income) of Fourth 20% of population in 2006 to that in 2009?
Offer a very short reply. 0.99. What is the ratio of the Income share held (as % of total income) in First 20% of population in 2006 to that in 2010?
Offer a very short reply. 1.09. What is the ratio of the Income share held (as % of total income) of Second 20% of population in 2006 to that in 2010?
Your answer should be compact. 0.93. What is the ratio of the Income share held (as % of total income) in Third 20% of population in 2006 to that in 2010?
Provide a succinct answer. 0.93. What is the ratio of the Income share held (as % of total income) of Fourth 20% of population in 2006 to that in 2010?
Keep it short and to the point. 0.97. What is the ratio of the Income share held (as % of total income) in First 20% of population in 2007 to that in 2008?
Provide a succinct answer. 0.95. What is the ratio of the Income share held (as % of total income) of Second 20% of population in 2007 to that in 2008?
Ensure brevity in your answer.  1.05. What is the ratio of the Income share held (as % of total income) in Fourth 20% of population in 2007 to that in 2008?
Your answer should be compact. 1.02. What is the ratio of the Income share held (as % of total income) of First 20% of population in 2007 to that in 2009?
Your answer should be very brief. 1.02. What is the ratio of the Income share held (as % of total income) of Second 20% of population in 2007 to that in 2009?
Your answer should be compact. 0.99. What is the ratio of the Income share held (as % of total income) of Third 20% of population in 2007 to that in 2009?
Make the answer very short. 0.97. What is the ratio of the Income share held (as % of total income) of First 20% of population in 2007 to that in 2010?
Your answer should be very brief. 1.08. What is the ratio of the Income share held (as % of total income) of Second 20% of population in 2007 to that in 2010?
Your answer should be compact. 0.94. What is the ratio of the Income share held (as % of total income) of Third 20% of population in 2007 to that in 2010?
Provide a short and direct response. 0.94. What is the ratio of the Income share held (as % of total income) in Fourth 20% of population in 2007 to that in 2010?
Offer a very short reply. 0.98. What is the ratio of the Income share held (as % of total income) of First 20% of population in 2008 to that in 2009?
Provide a succinct answer. 1.07. What is the ratio of the Income share held (as % of total income) of Second 20% of population in 2008 to that in 2009?
Make the answer very short. 0.94. What is the ratio of the Income share held (as % of total income) in Third 20% of population in 2008 to that in 2009?
Keep it short and to the point. 0.95. What is the ratio of the Income share held (as % of total income) of Fourth 20% of population in 2008 to that in 2009?
Offer a terse response. 0.97. What is the ratio of the Income share held (as % of total income) in First 20% of population in 2008 to that in 2010?
Your answer should be compact. 1.13. What is the ratio of the Income share held (as % of total income) in Second 20% of population in 2008 to that in 2010?
Keep it short and to the point. 0.9. What is the ratio of the Income share held (as % of total income) of Third 20% of population in 2008 to that in 2010?
Your answer should be very brief. 0.91. What is the ratio of the Income share held (as % of total income) in Fourth 20% of population in 2008 to that in 2010?
Offer a very short reply. 0.96. What is the ratio of the Income share held (as % of total income) in First 20% of population in 2009 to that in 2010?
Provide a short and direct response. 1.06. What is the ratio of the Income share held (as % of total income) in Second 20% of population in 2009 to that in 2010?
Your answer should be very brief. 0.95. What is the ratio of the Income share held (as % of total income) in Third 20% of population in 2009 to that in 2010?
Offer a very short reply. 0.96. What is the ratio of the Income share held (as % of total income) in Fourth 20% of population in 2009 to that in 2010?
Give a very brief answer. 0.98. What is the difference between the highest and the second highest Income share held (as % of total income) in First 20% of population?
Your response must be concise. 1.38. What is the difference between the highest and the second highest Income share held (as % of total income) of Second 20% of population?
Offer a very short reply. 0.66. What is the difference between the highest and the second highest Income share held (as % of total income) in Third 20% of population?
Give a very brief answer. 0.69. What is the difference between the highest and the second highest Income share held (as % of total income) in Fourth 20% of population?
Keep it short and to the point. 0.36. What is the difference between the highest and the lowest Income share held (as % of total income) in First 20% of population?
Offer a terse response. 4.79. What is the difference between the highest and the lowest Income share held (as % of total income) of Second 20% of population?
Your answer should be very brief. 1.47. What is the difference between the highest and the lowest Income share held (as % of total income) of Third 20% of population?
Make the answer very short. 1.57. 